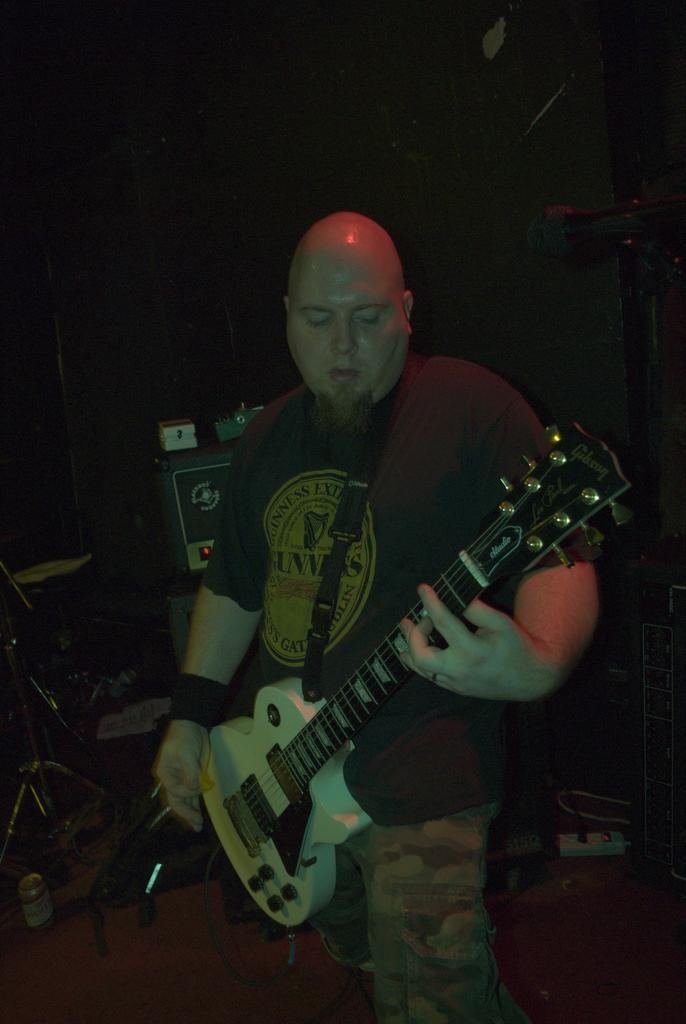What is the person in the image wearing? The person is wearing a black t-shirt in the image. What is the person doing in the image? The person is playing a guitar in the image. What else can be seen in the background of the image? There are musical instruments in the background of the image. Where is the microphone located in the image? The microphone is on the right side of the image. What type of dog can be seen playing with the guitar in the image? There is no dog present in the image, and the guitar is being played by the person, not a dog. What date is circled on the calendar in the image? There is no calendar present in the image, so it is not possible to answer this question. 